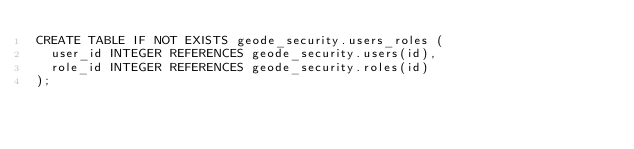<code> <loc_0><loc_0><loc_500><loc_500><_SQL_>CREATE TABLE IF NOT EXISTS geode_security.users_roles (
  user_id INTEGER REFERENCES geode_security.users(id),
  role_id INTEGER REFERENCES geode_security.roles(id)
);
</code> 